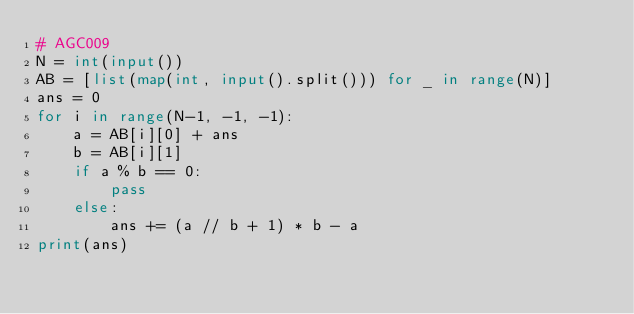<code> <loc_0><loc_0><loc_500><loc_500><_Python_># AGC009
N = int(input())
AB = [list(map(int, input().split())) for _ in range(N)]
ans = 0
for i in range(N-1, -1, -1):
    a = AB[i][0] + ans
    b = AB[i][1]
    if a % b == 0:
        pass
    else:
        ans += (a // b + 1) * b - a
print(ans)</code> 